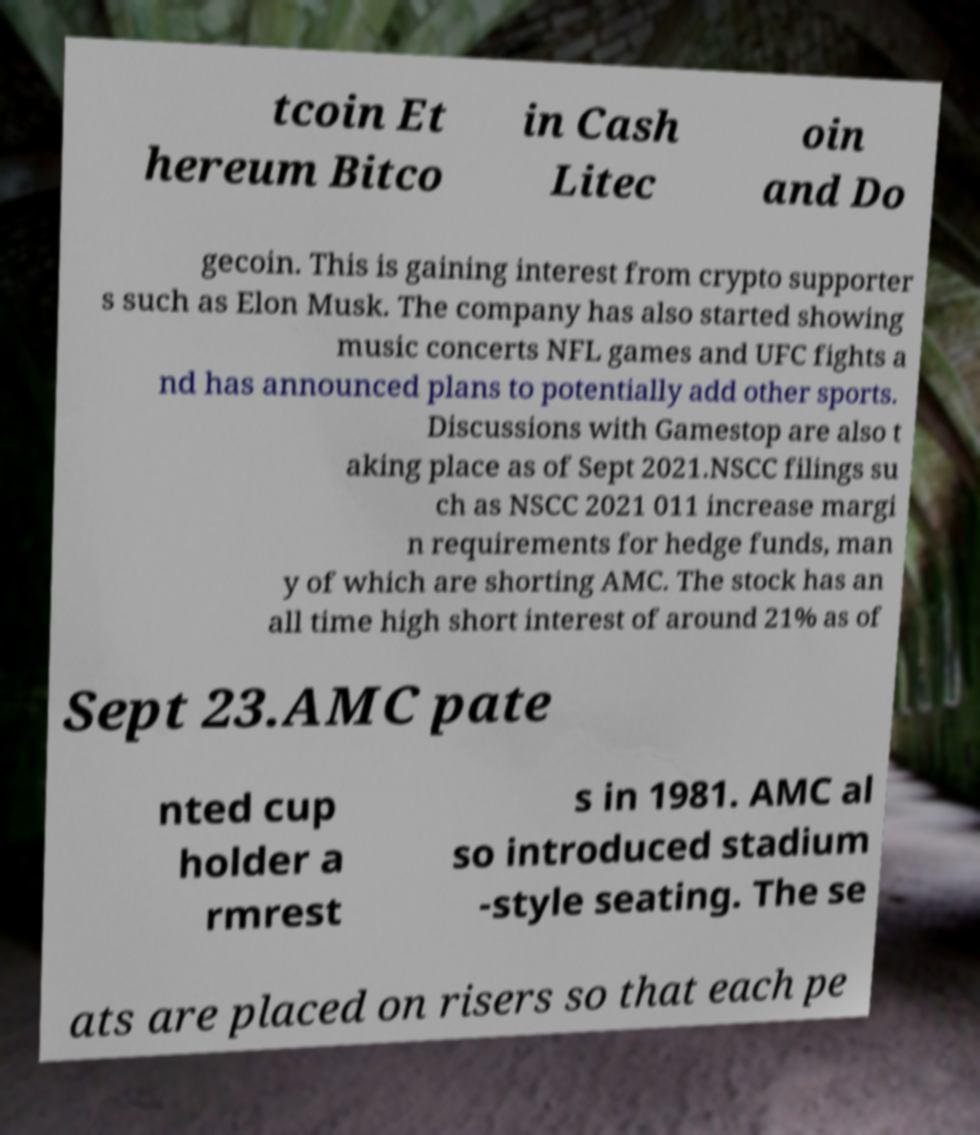Could you assist in decoding the text presented in this image and type it out clearly? tcoin Et hereum Bitco in Cash Litec oin and Do gecoin. This is gaining interest from crypto supporter s such as Elon Musk. The company has also started showing music concerts NFL games and UFC fights a nd has announced plans to potentially add other sports. Discussions with Gamestop are also t aking place as of Sept 2021.NSCC filings su ch as NSCC 2021 011 increase margi n requirements for hedge funds, man y of which are shorting AMC. The stock has an all time high short interest of around 21% as of Sept 23.AMC pate nted cup holder a rmrest s in 1981. AMC al so introduced stadium -style seating. The se ats are placed on risers so that each pe 